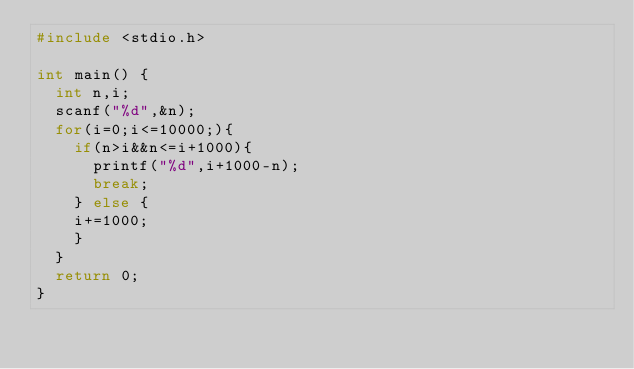<code> <loc_0><loc_0><loc_500><loc_500><_C_>#include <stdio.h>

int main() {
  int n,i;
  scanf("%d",&n);
  for(i=0;i<=10000;){
    if(n>i&&n<=i+1000){
      printf("%d",i+1000-n);
      break;
    } else {
    i+=1000;
    }
  }
  return 0;
}
</code> 